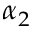Convert formula to latex. <formula><loc_0><loc_0><loc_500><loc_500>\alpha _ { 2 }</formula> 